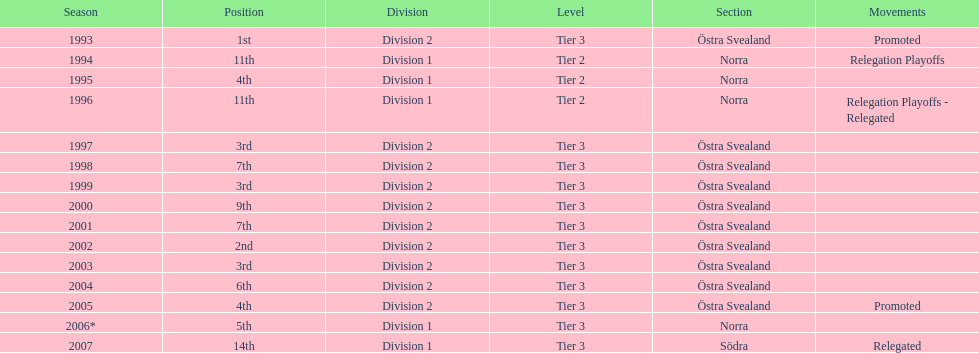In what season did visby if gute fk finish first in division 2 tier 3? 1993. 